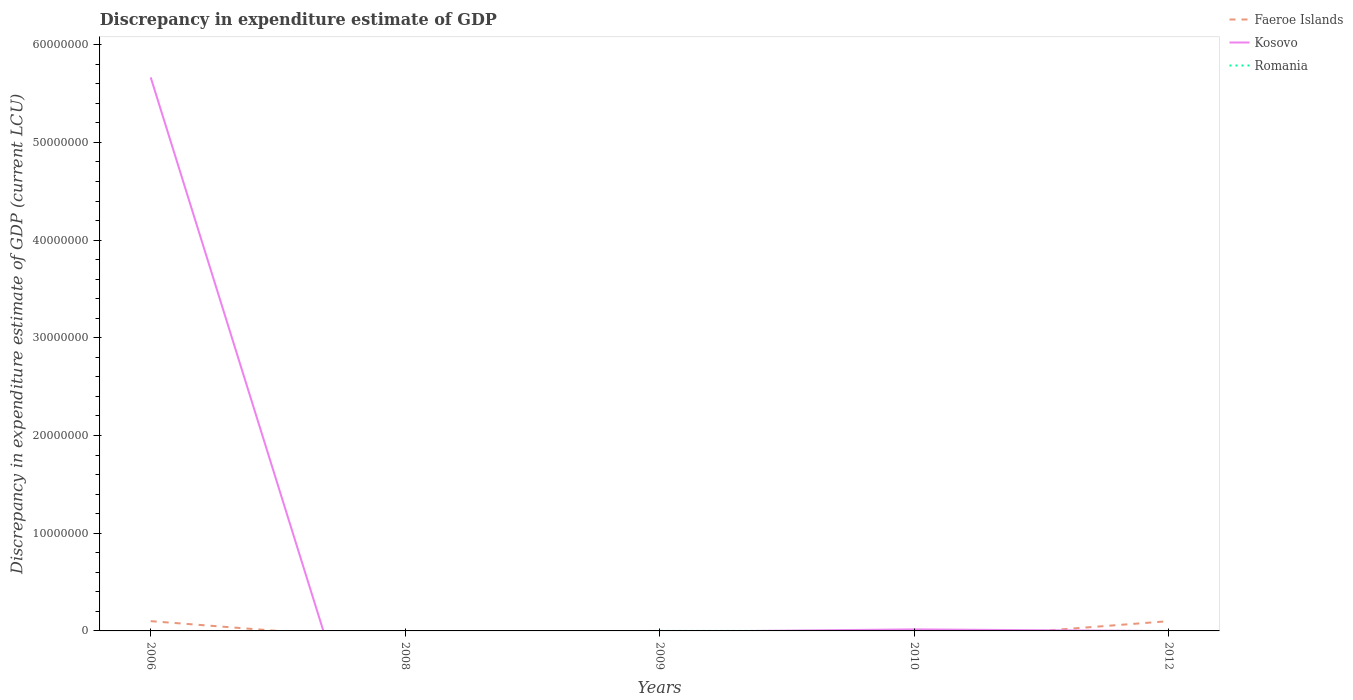Does the line corresponding to Faeroe Islands intersect with the line corresponding to Romania?
Offer a terse response. Yes. Across all years, what is the maximum discrepancy in expenditure estimate of GDP in Faeroe Islands?
Provide a succinct answer. 0. What is the total discrepancy in expenditure estimate of GDP in Faeroe Islands in the graph?
Provide a succinct answer. 0. What is the difference between the highest and the second highest discrepancy in expenditure estimate of GDP in Kosovo?
Your response must be concise. 5.67e+07. What is the difference between the highest and the lowest discrepancy in expenditure estimate of GDP in Romania?
Keep it short and to the point. 1. How many lines are there?
Provide a succinct answer. 3. What is the difference between two consecutive major ticks on the Y-axis?
Your answer should be very brief. 1.00e+07. Does the graph contain grids?
Your response must be concise. No. Where does the legend appear in the graph?
Provide a short and direct response. Top right. How many legend labels are there?
Your answer should be compact. 3. What is the title of the graph?
Your answer should be compact. Discrepancy in expenditure estimate of GDP. What is the label or title of the X-axis?
Give a very brief answer. Years. What is the label or title of the Y-axis?
Keep it short and to the point. Discrepancy in expenditure estimate of GDP (current LCU). What is the Discrepancy in expenditure estimate of GDP (current LCU) in Faeroe Islands in 2006?
Provide a short and direct response. 1.00e+06. What is the Discrepancy in expenditure estimate of GDP (current LCU) of Kosovo in 2006?
Offer a terse response. 5.67e+07. What is the Discrepancy in expenditure estimate of GDP (current LCU) of Faeroe Islands in 2008?
Make the answer very short. 0. What is the Discrepancy in expenditure estimate of GDP (current LCU) of Kosovo in 2008?
Your answer should be very brief. 0. What is the Discrepancy in expenditure estimate of GDP (current LCU) in Kosovo in 2009?
Your answer should be very brief. 0. What is the Discrepancy in expenditure estimate of GDP (current LCU) in Faeroe Islands in 2010?
Provide a succinct answer. 0. What is the Discrepancy in expenditure estimate of GDP (current LCU) in Kosovo in 2010?
Your answer should be very brief. 1.59e+05. What is the Discrepancy in expenditure estimate of GDP (current LCU) of Romania in 2010?
Make the answer very short. 1.5e-5. What is the Discrepancy in expenditure estimate of GDP (current LCU) of Romania in 2012?
Keep it short and to the point. 0. Across all years, what is the maximum Discrepancy in expenditure estimate of GDP (current LCU) of Faeroe Islands?
Your answer should be very brief. 1.00e+06. Across all years, what is the maximum Discrepancy in expenditure estimate of GDP (current LCU) of Kosovo?
Keep it short and to the point. 5.67e+07. Across all years, what is the maximum Discrepancy in expenditure estimate of GDP (current LCU) in Romania?
Your answer should be very brief. 1.5e-5. Across all years, what is the minimum Discrepancy in expenditure estimate of GDP (current LCU) in Faeroe Islands?
Your answer should be very brief. 0. Across all years, what is the minimum Discrepancy in expenditure estimate of GDP (current LCU) in Romania?
Ensure brevity in your answer.  0. What is the total Discrepancy in expenditure estimate of GDP (current LCU) of Kosovo in the graph?
Provide a short and direct response. 5.68e+07. What is the total Discrepancy in expenditure estimate of GDP (current LCU) in Romania in the graph?
Offer a terse response. 0. What is the difference between the Discrepancy in expenditure estimate of GDP (current LCU) of Kosovo in 2006 and that in 2010?
Provide a succinct answer. 5.65e+07. What is the difference between the Discrepancy in expenditure estimate of GDP (current LCU) of Faeroe Islands in 2006 and the Discrepancy in expenditure estimate of GDP (current LCU) of Kosovo in 2010?
Keep it short and to the point. 8.41e+05. What is the difference between the Discrepancy in expenditure estimate of GDP (current LCU) of Faeroe Islands in 2006 and the Discrepancy in expenditure estimate of GDP (current LCU) of Romania in 2010?
Keep it short and to the point. 1.00e+06. What is the difference between the Discrepancy in expenditure estimate of GDP (current LCU) of Kosovo in 2006 and the Discrepancy in expenditure estimate of GDP (current LCU) of Romania in 2010?
Make the answer very short. 5.67e+07. What is the average Discrepancy in expenditure estimate of GDP (current LCU) in Kosovo per year?
Provide a short and direct response. 1.14e+07. What is the average Discrepancy in expenditure estimate of GDP (current LCU) in Romania per year?
Your answer should be very brief. 0. In the year 2006, what is the difference between the Discrepancy in expenditure estimate of GDP (current LCU) in Faeroe Islands and Discrepancy in expenditure estimate of GDP (current LCU) in Kosovo?
Give a very brief answer. -5.57e+07. In the year 2010, what is the difference between the Discrepancy in expenditure estimate of GDP (current LCU) of Kosovo and Discrepancy in expenditure estimate of GDP (current LCU) of Romania?
Offer a very short reply. 1.59e+05. What is the ratio of the Discrepancy in expenditure estimate of GDP (current LCU) of Kosovo in 2006 to that in 2010?
Provide a succinct answer. 356.33. What is the ratio of the Discrepancy in expenditure estimate of GDP (current LCU) in Faeroe Islands in 2006 to that in 2012?
Make the answer very short. 1. What is the difference between the highest and the lowest Discrepancy in expenditure estimate of GDP (current LCU) of Kosovo?
Ensure brevity in your answer.  5.67e+07. What is the difference between the highest and the lowest Discrepancy in expenditure estimate of GDP (current LCU) of Romania?
Provide a succinct answer. 0. 